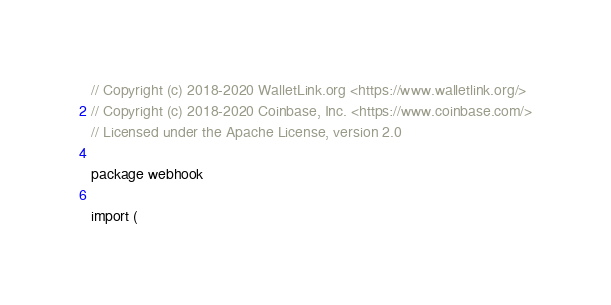Convert code to text. <code><loc_0><loc_0><loc_500><loc_500><_Go_>// Copyright (c) 2018-2020 WalletLink.org <https://www.walletlink.org/>
// Copyright (c) 2018-2020 Coinbase, Inc. <https://www.coinbase.com/>
// Licensed under the Apache License, version 2.0

package webhook

import (</code> 